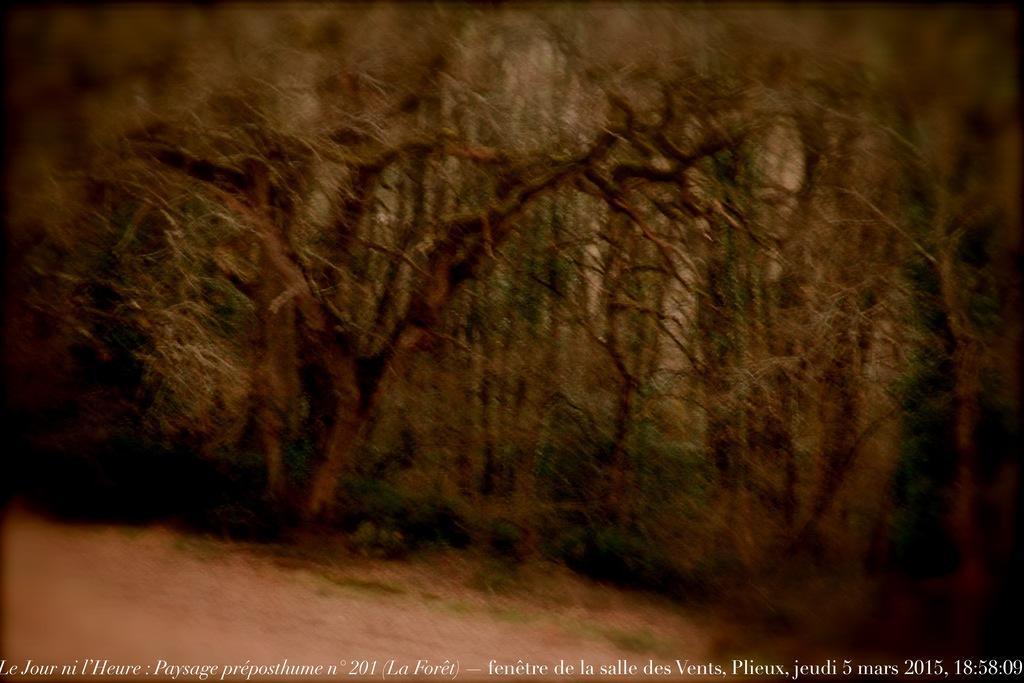Please provide a concise description of this image. In the center of the image there are trees. 